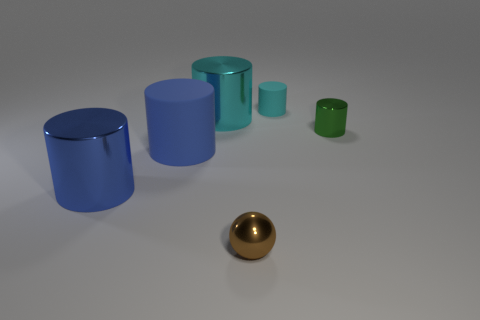Subtract all small green cylinders. How many cylinders are left? 4 Subtract all brown balls. How many cyan cylinders are left? 2 Subtract all cyan cylinders. How many cylinders are left? 3 Add 3 gray blocks. How many objects exist? 9 Subtract all brown cylinders. Subtract all red blocks. How many cylinders are left? 5 Subtract all balls. How many objects are left? 5 Subtract 1 green cylinders. How many objects are left? 5 Subtract all cyan metal things. Subtract all green shiny things. How many objects are left? 4 Add 4 green things. How many green things are left? 5 Add 2 tiny things. How many tiny things exist? 5 